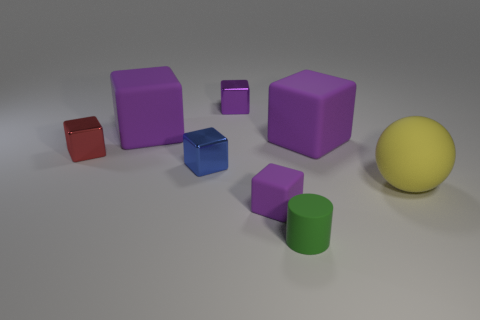Subtract all large purple rubber cubes. How many cubes are left? 4 Subtract 1 balls. How many balls are left? 0 Add 1 rubber objects. How many objects exist? 9 Subtract all spheres. How many objects are left? 7 Subtract all blue cubes. How many cubes are left? 5 Subtract 0 brown blocks. How many objects are left? 8 Subtract all blue cubes. Subtract all yellow balls. How many cubes are left? 5 Subtract all red cylinders. How many cyan spheres are left? 0 Subtract all small cubes. Subtract all tiny green things. How many objects are left? 3 Add 6 small red shiny things. How many small red shiny things are left? 7 